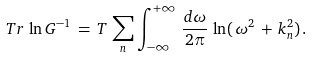Convert formula to latex. <formula><loc_0><loc_0><loc_500><loc_500>T r \, \ln G ^ { - 1 } \, = \, T \, \sum _ { n } \int _ { - \infty } ^ { + \infty } \, \frac { d \omega } { 2 \pi } \, \ln ( \, \omega ^ { 2 } \, + \, k _ { n } ^ { 2 } ) \, { . }</formula> 